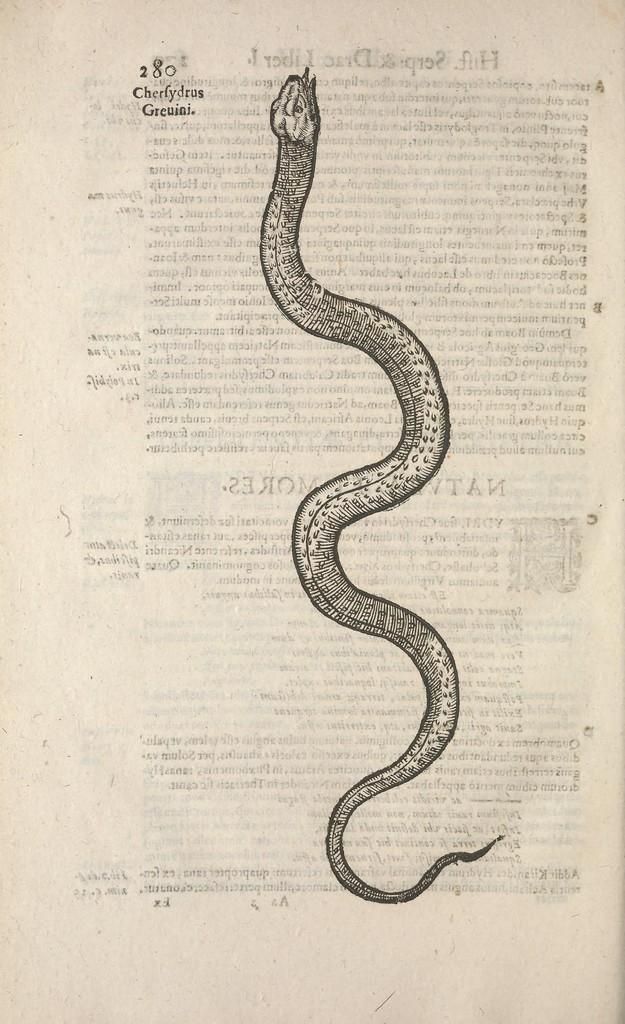What is depicted on the paper in the image? There is a drawing of a snake on a paper. Can you describe any additional elements in the image? Yes, there is text in the background of the snake drawing. What type of letter is being sent from the airport in the image? There is no airport or letter present in the image; it only features a drawing of a snake on a paper with text in the background. 